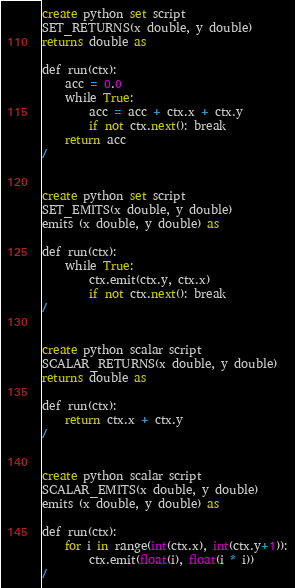<code> <loc_0><loc_0><loc_500><loc_500><_SQL_>create python set script
SET_RETURNS(x double, y double)
returns double as

def run(ctx):
    acc = 0.0
    while True:
        acc = acc + ctx.x + ctx.y
        if not ctx.next(): break
    return acc
/


create python set script
SET_EMITS(x double, y double)
emits (x double, y double) as

def run(ctx):
    while True:
        ctx.emit(ctx.y, ctx.x)
        if not ctx.next(): break
/


create python scalar script
SCALAR_RETURNS(x double, y double)
returns double as

def run(ctx):
    return ctx.x + ctx.y
/


create python scalar script
SCALAR_EMITS(x double, y double)
emits (x double, y double) as

def run(ctx):
    for i in range(int(ctx.x), int(ctx.y+1)):
        ctx.emit(float(i), float(i * i))
/
</code> 